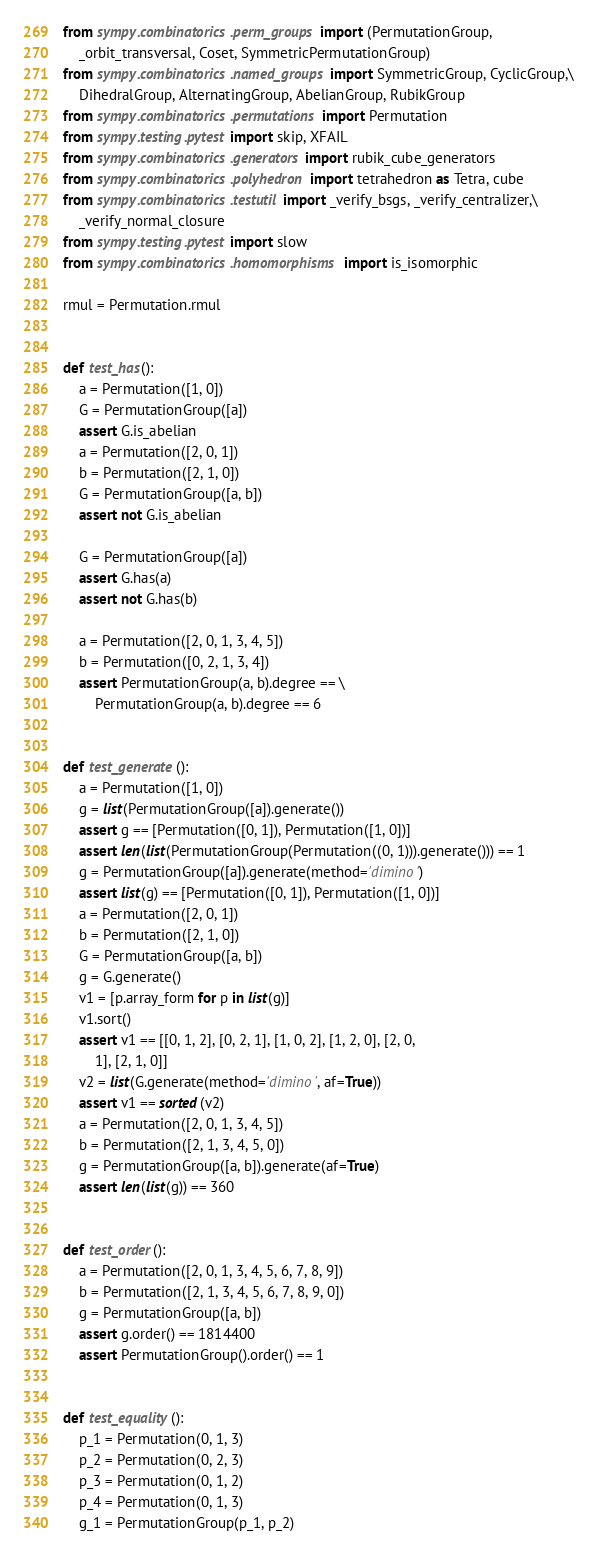<code> <loc_0><loc_0><loc_500><loc_500><_Python_>from sympy.combinatorics.perm_groups import (PermutationGroup,
    _orbit_transversal, Coset, SymmetricPermutationGroup)
from sympy.combinatorics.named_groups import SymmetricGroup, CyclicGroup,\
    DihedralGroup, AlternatingGroup, AbelianGroup, RubikGroup
from sympy.combinatorics.permutations import Permutation
from sympy.testing.pytest import skip, XFAIL
from sympy.combinatorics.generators import rubik_cube_generators
from sympy.combinatorics.polyhedron import tetrahedron as Tetra, cube
from sympy.combinatorics.testutil import _verify_bsgs, _verify_centralizer,\
    _verify_normal_closure
from sympy.testing.pytest import slow
from sympy.combinatorics.homomorphisms import is_isomorphic

rmul = Permutation.rmul


def test_has():
    a = Permutation([1, 0])
    G = PermutationGroup([a])
    assert G.is_abelian
    a = Permutation([2, 0, 1])
    b = Permutation([2, 1, 0])
    G = PermutationGroup([a, b])
    assert not G.is_abelian

    G = PermutationGroup([a])
    assert G.has(a)
    assert not G.has(b)

    a = Permutation([2, 0, 1, 3, 4, 5])
    b = Permutation([0, 2, 1, 3, 4])
    assert PermutationGroup(a, b).degree == \
        PermutationGroup(a, b).degree == 6


def test_generate():
    a = Permutation([1, 0])
    g = list(PermutationGroup([a]).generate())
    assert g == [Permutation([0, 1]), Permutation([1, 0])]
    assert len(list(PermutationGroup(Permutation((0, 1))).generate())) == 1
    g = PermutationGroup([a]).generate(method='dimino')
    assert list(g) == [Permutation([0, 1]), Permutation([1, 0])]
    a = Permutation([2, 0, 1])
    b = Permutation([2, 1, 0])
    G = PermutationGroup([a, b])
    g = G.generate()
    v1 = [p.array_form for p in list(g)]
    v1.sort()
    assert v1 == [[0, 1, 2], [0, 2, 1], [1, 0, 2], [1, 2, 0], [2, 0,
        1], [2, 1, 0]]
    v2 = list(G.generate(method='dimino', af=True))
    assert v1 == sorted(v2)
    a = Permutation([2, 0, 1, 3, 4, 5])
    b = Permutation([2, 1, 3, 4, 5, 0])
    g = PermutationGroup([a, b]).generate(af=True)
    assert len(list(g)) == 360


def test_order():
    a = Permutation([2, 0, 1, 3, 4, 5, 6, 7, 8, 9])
    b = Permutation([2, 1, 3, 4, 5, 6, 7, 8, 9, 0])
    g = PermutationGroup([a, b])
    assert g.order() == 1814400
    assert PermutationGroup().order() == 1


def test_equality():
    p_1 = Permutation(0, 1, 3)
    p_2 = Permutation(0, 2, 3)
    p_3 = Permutation(0, 1, 2)
    p_4 = Permutation(0, 1, 3)
    g_1 = PermutationGroup(p_1, p_2)</code> 